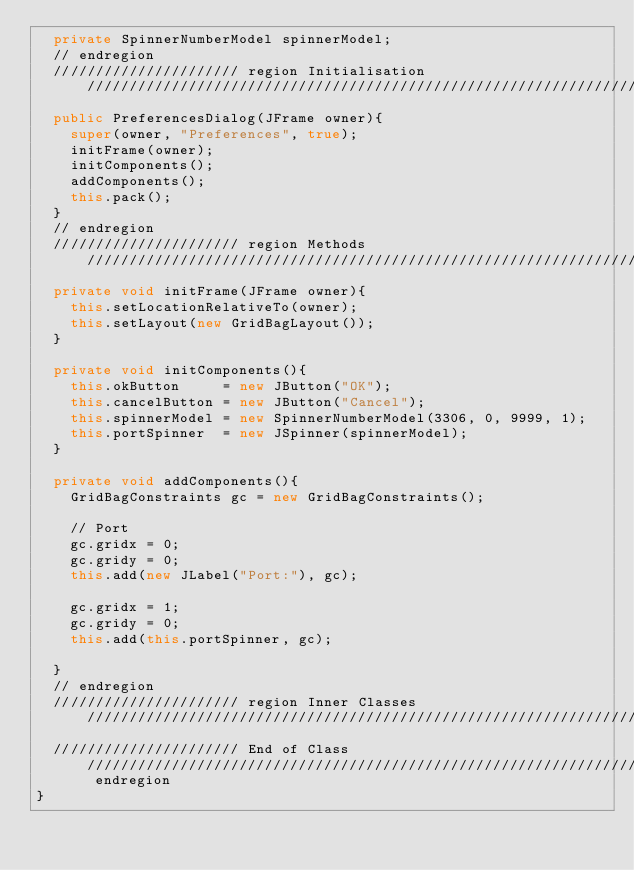Convert code to text. <code><loc_0><loc_0><loc_500><loc_500><_Java_>  private SpinnerNumberModel spinnerModel;
  // endregion
  ////////////////////// region Initialisation /////////////////////////////////////////////////////////////////////////////////////////////////////////////////
  public PreferencesDialog(JFrame owner){
    super(owner, "Preferences", true);
    initFrame(owner);
    initComponents();
    addComponents();
    this.pack();
  }
  // endregion
  ////////////////////// region Methods ////////////////////////////////////////////////////////////////////////////////////////////////////////////////////////
  private void initFrame(JFrame owner){
    this.setLocationRelativeTo(owner);
    this.setLayout(new GridBagLayout());
  }

  private void initComponents(){
    this.okButton     = new JButton("OK");
    this.cancelButton = new JButton("Cancel");
    this.spinnerModel = new SpinnerNumberModel(3306, 0, 9999, 1);
    this.portSpinner  = new JSpinner(spinnerModel);
  }

  private void addComponents(){
    GridBagConstraints gc = new GridBagConstraints();

    // Port
    gc.gridx = 0;
    gc.gridy = 0;
    this.add(new JLabel("Port:"), gc);

    gc.gridx = 1;
    gc.gridy = 0;
    this.add(this.portSpinner, gc);

  }
  // endregion
  ////////////////////// region Inner Classes //////////////////////////////////////////////////////////////////////////////////////////////////////////////////
  ////////////////////// End of Class //////////////////////////////////////////////////////////////////////////////////////////////////////////////// endregion
}

</code> 